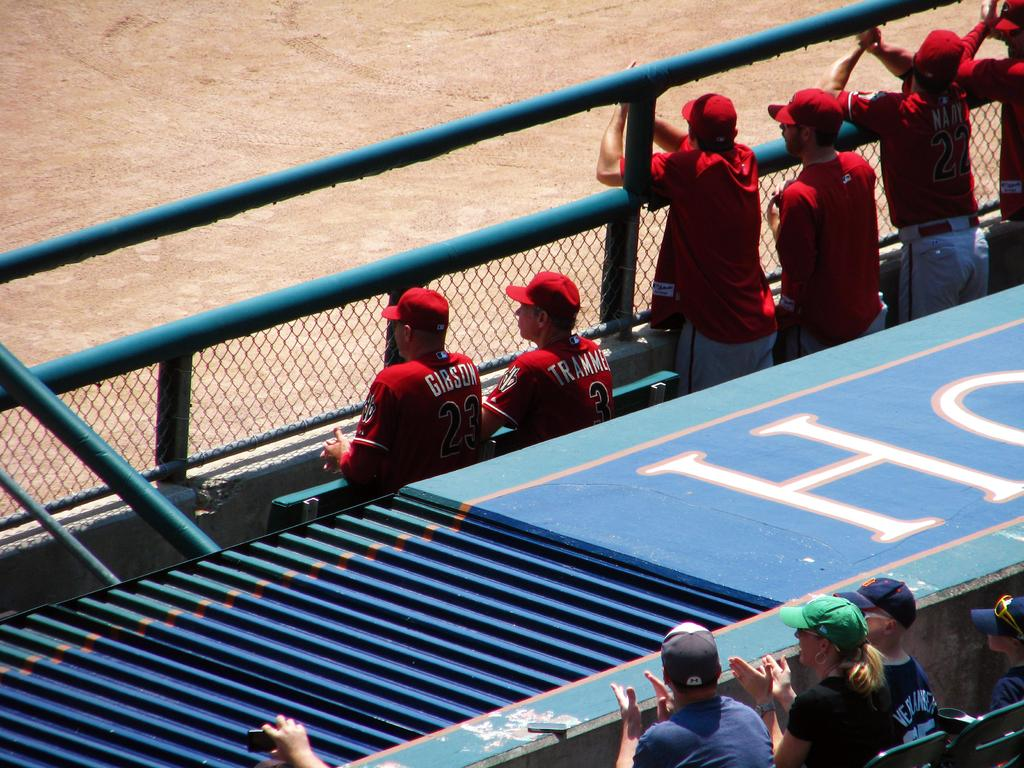How many people are in the image? There are people in the image, but the exact number is not specified. What are some of the people doing in the image? Some people are sitting on chairs, and some are standing. What can be seen in the background of the image? There is a fence and a stage in the image. What is visible beneath the people in the image? The ground is visible in the image. What type of pen is being used by the person on stage in the image? There is no pen visible in the image, and no person is specifically mentioned as being on stage. 